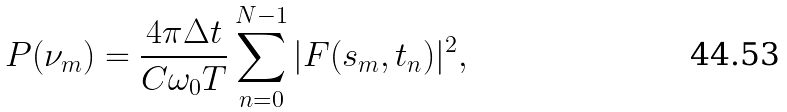<formula> <loc_0><loc_0><loc_500><loc_500>P ( \nu _ { m } ) = \frac { 4 \pi \Delta t } { C \omega _ { 0 } T } \sum _ { n = 0 } ^ { N - 1 } | F ( s _ { m } , t _ { n } ) | ^ { 2 } ,</formula> 